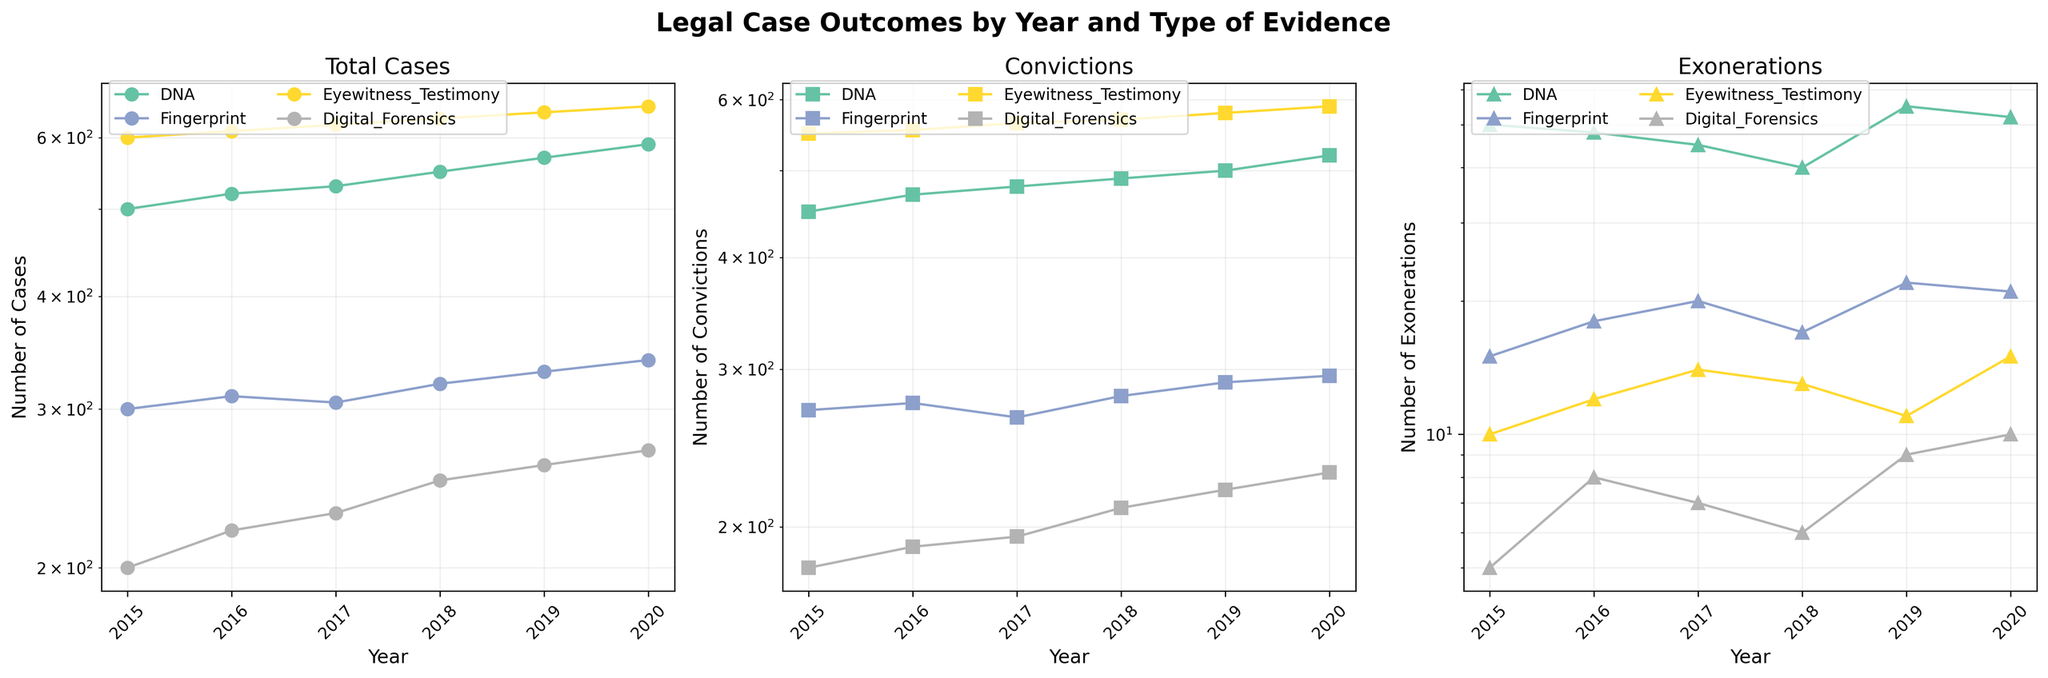How many different types of evidence are presented in the figure? The legend in each subplot shows different lines corresponding to different types of evidence. Each unique color and label combination indicates a different type of evidence. Count the distinct evidence types labeled in the legend.
Answer: Four Which type of evidence had the highest number of exonerations in 2020? Look at the 'Exonerations' subplot for the year 2020, and identify the evidence type that reaches the highest point on the y-axis.
Answer: DNA What is the trend for the number of cases involving digital forensics from 2015 to 2020? Follow the line associated with 'Digital Forensics' in the 'Total Cases' subplot. Observe whether the line is generally increasing, decreasing, or remaining constant over the years.
Answer: Increasing How many total convictions were made using DNA evidence in 2019? Locate the point corresponding to 2019 in the 'Convictions' subplot and follow the line for DNA evidence. Read off the y-axis value.
Answer: 500 From 2015 to 2020, in which year did fingerprint evidence have the highest number of convictions? Observe the 'Convictions' subplot and follow the line for fingerprint evidence. Identify the year where the line peaks.
Answer: 2019 Compare the number of cases involving eyewitness testimony between 2015 and 2020. Which year had more cases? Check the 'Total Cases' subplot for the points labeled '2015' and '2020'. Compare the corresponding values for 'Eyewitness Testimony'.
Answer: 2020 had more cases What is the overall trend in the number of exonerations involving fingerprint evidence from 2015 to 2020? Examine the 'Exonerations' subplot and follow the line for fingerprint evidence from 2015 to 2020. Determine if the trend is upward, downward, or stable.
Answer: Increasing What is the difference in the number of exonerations between DNA and digital forensics evidence in 2020? In the 'Exonerations' subplot, read the values for DNA and digital forensics in the year 2020 and subtract the smaller value from the larger one.
Answer: 42 Which type of evidence consistently shows the highest number of convictions each year? In the 'Convictions' subplot, compare the lines for all evidence types across the years to see which one is at the top most consistently.
Answer: DNA Considering the log scale of the y-axis, describe the trend in the number of total cases involving fingerprint evidence from 2015 to 2020. In the 'Total Cases' subplot, observe the line for fingerprint evidence. Although the y-axis is log-scaled, determine if the line is generally moving upward, downward, or staying flat.
Answer: Increasing 